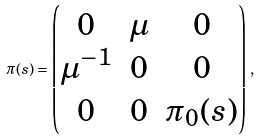<formula> <loc_0><loc_0><loc_500><loc_500>\pi ( s ) = \begin{pmatrix} 0 & \mu & 0 \\ \mu ^ { - 1 } & 0 & 0 \\ 0 & 0 & \pi _ { 0 } ( s ) \end{pmatrix} \, ,</formula> 